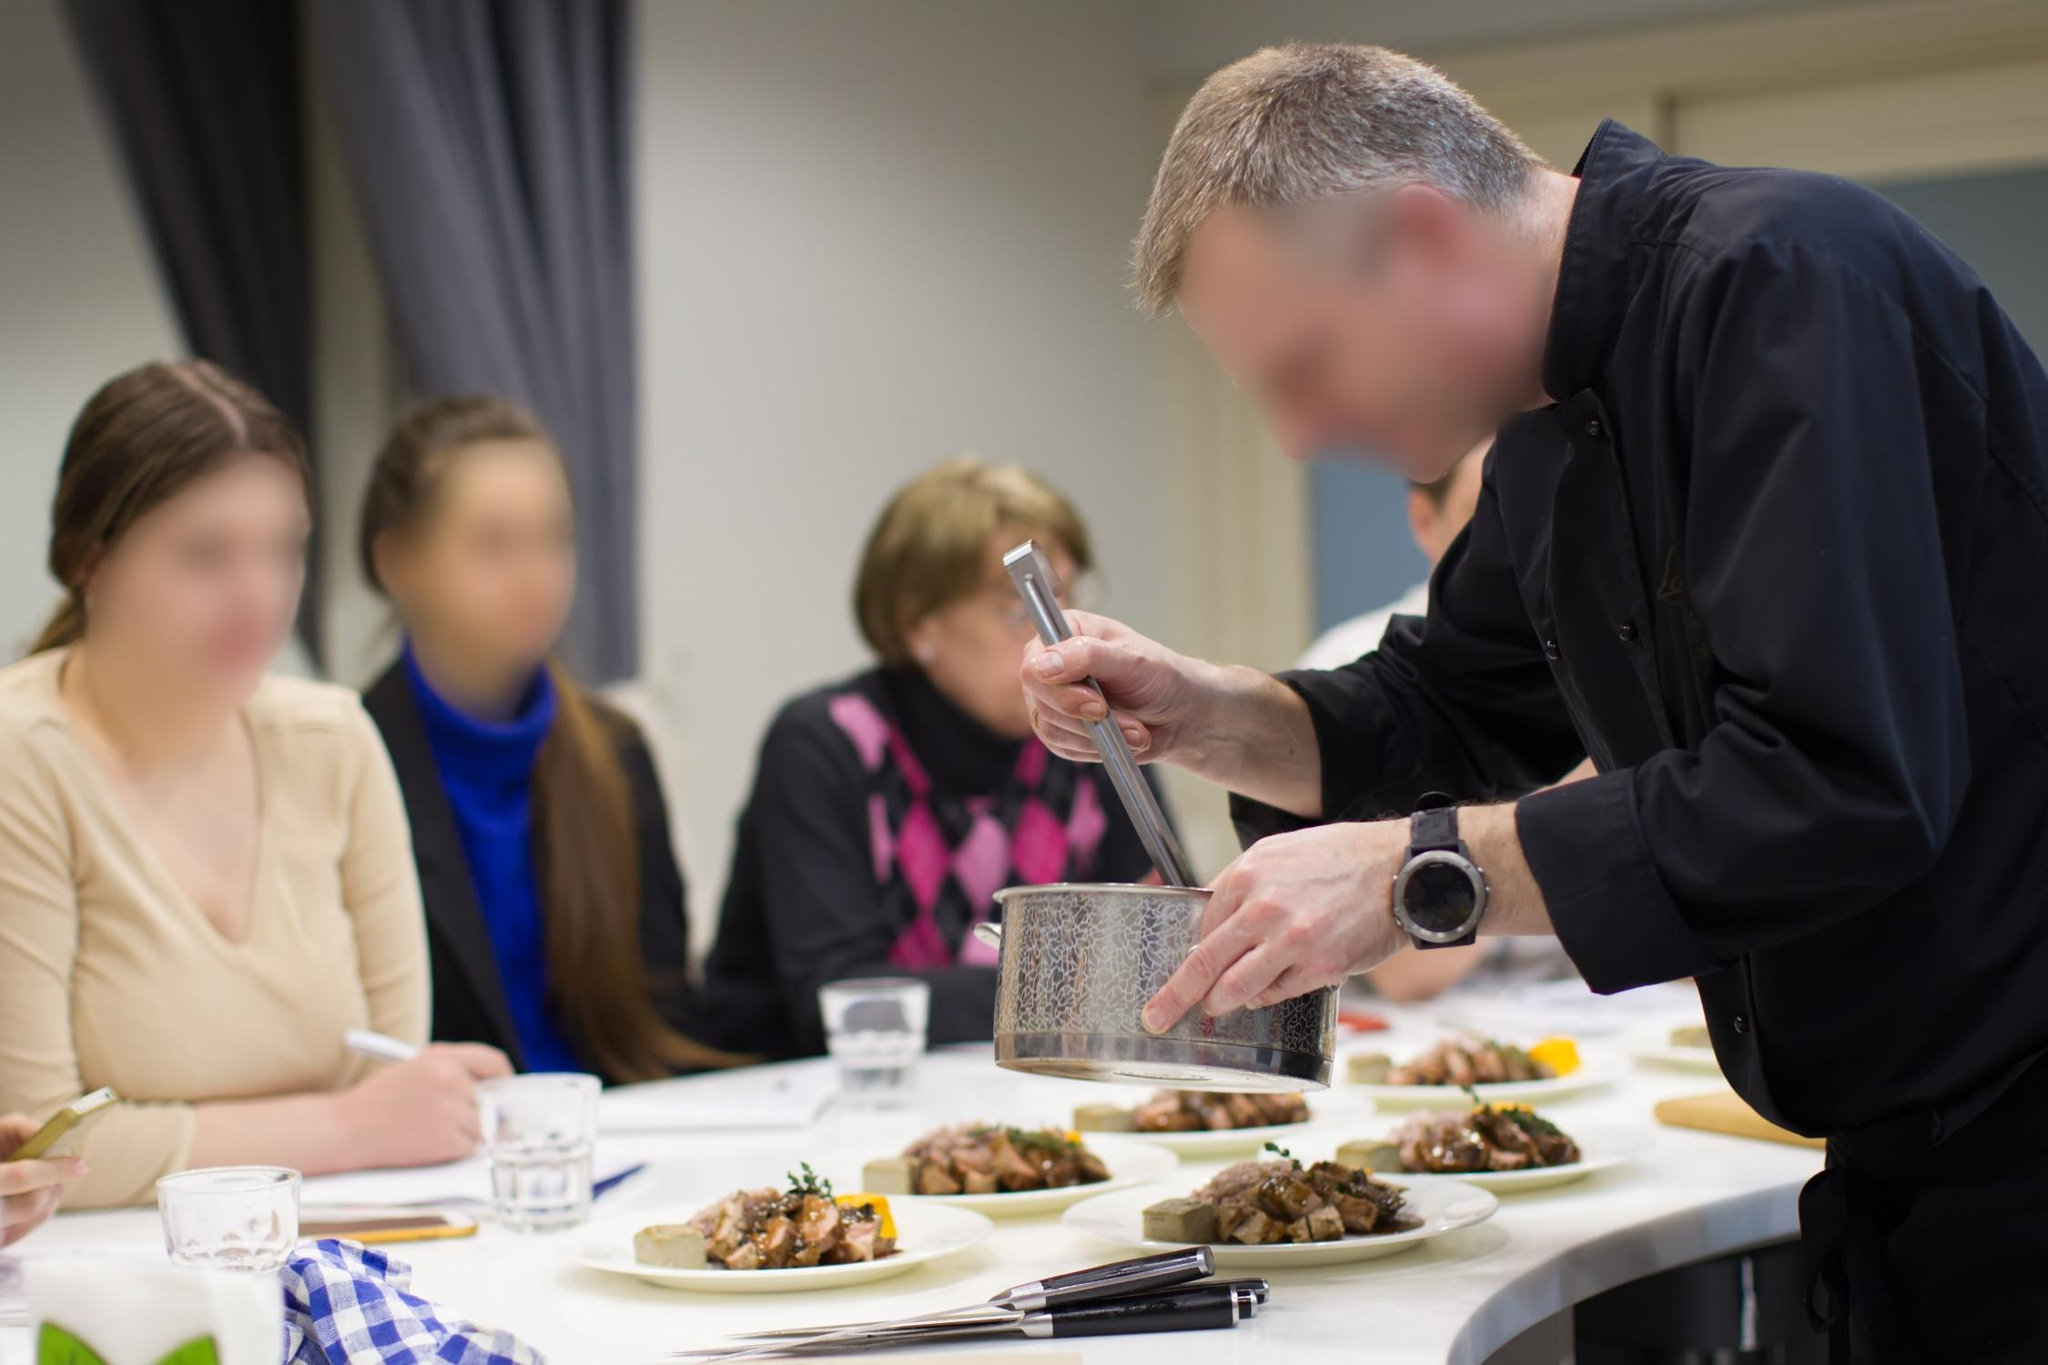What is happening in this image? In the image, a chef is in the midst of a cooking demonstration or class. He is grating cheese over plates of food on a counter, showcasing his culinary skills to a small audience of three individuals who are seated and observing him attentively. The kitchen is brightly lit, creating a warm and inviting atmosphere for this interactive and educational culinary experience. 